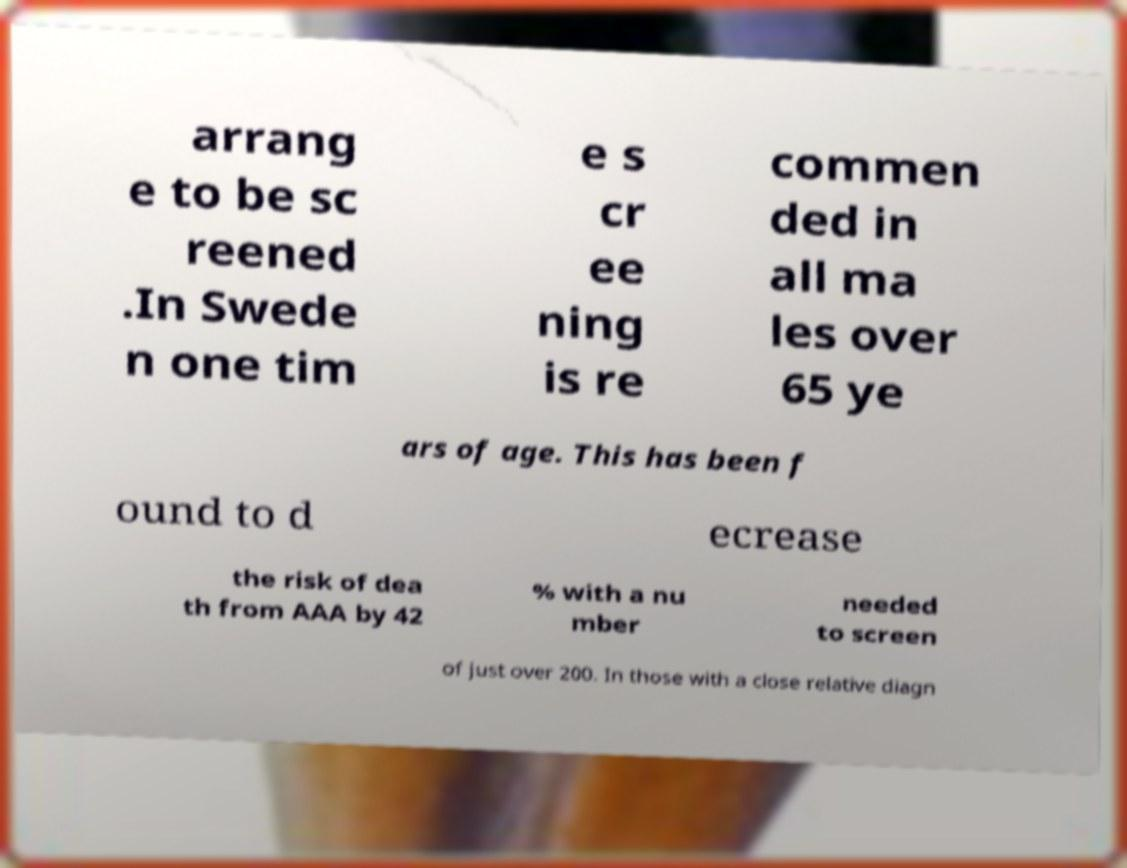Please identify and transcribe the text found in this image. arrang e to be sc reened .In Swede n one tim e s cr ee ning is re commen ded in all ma les over 65 ye ars of age. This has been f ound to d ecrease the risk of dea th from AAA by 42 % with a nu mber needed to screen of just over 200. In those with a close relative diagn 